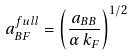Convert formula to latex. <formula><loc_0><loc_0><loc_500><loc_500>a _ { B F } ^ { f u l l } = \left ( \frac { a _ { B B } } { \alpha \, k _ { F } } \right ) ^ { 1 / 2 }</formula> 